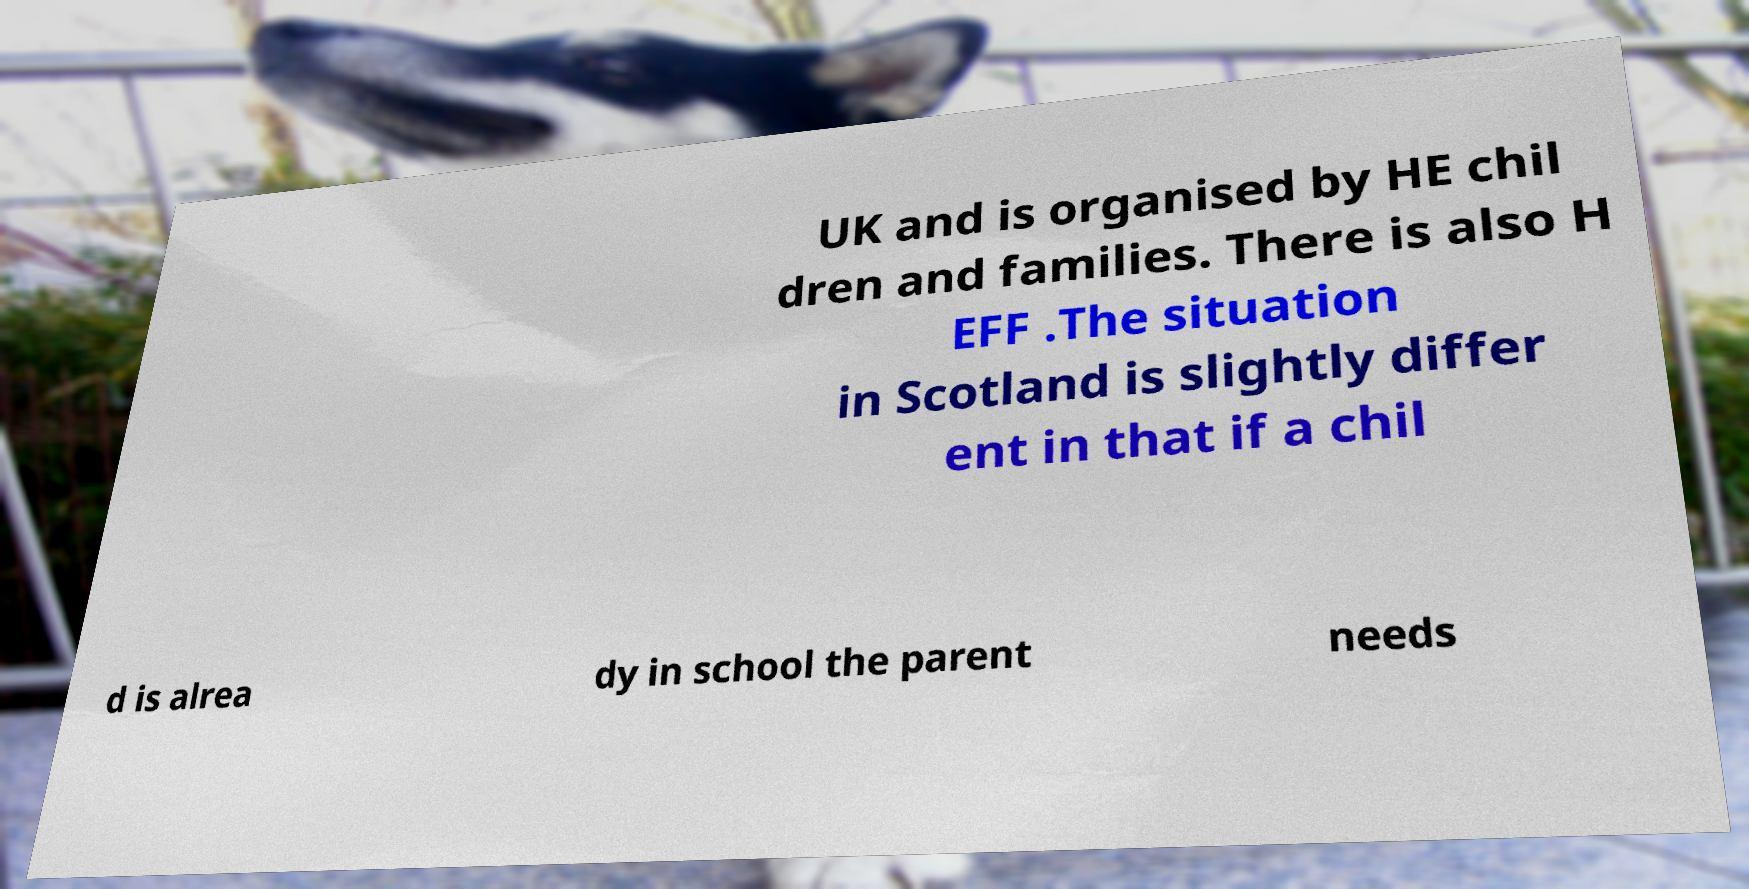Please read and relay the text visible in this image. What does it say? UK and is organised by HE chil dren and families. There is also H EFF .The situation in Scotland is slightly differ ent in that if a chil d is alrea dy in school the parent needs 